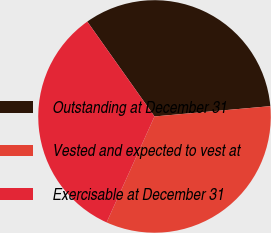<chart> <loc_0><loc_0><loc_500><loc_500><pie_chart><fcel>Outstanding at December 31<fcel>Vested and expected to vest at<fcel>Exercisable at December 31<nl><fcel>33.4%<fcel>33.17%<fcel>33.43%<nl></chart> 